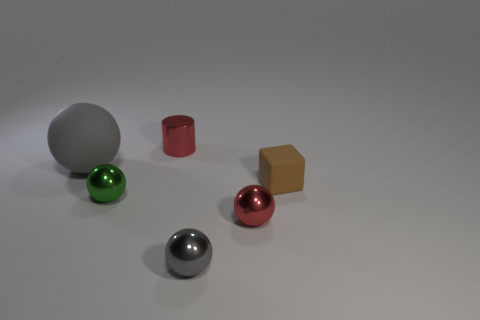What do the different colors and shapes in the picture suggest about the objects' materials? The colors and shapes of the objects suggest different materials and finishes. For example, the reflective quality of the silver metal cylinder and silver sphere suggest they are likely made of metal, while the matte finish of the red cylinder could indicate a painted surface. The spheres could be decorative, and the cube, with its gold color, might represent something valuable or significant, possibly used as a paperweight or ornamental object. 